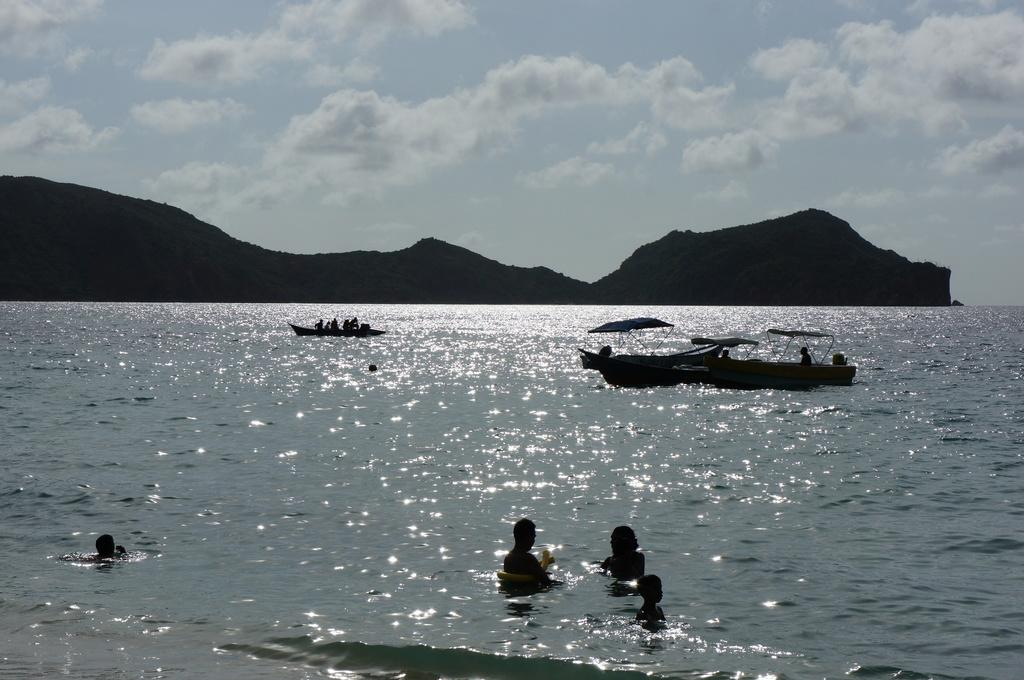What is the main setting of the image? There is a sea in the image. What are the people in the image doing? There are people swimming in the sea. What else can be seen on the sea in the image? There are boats sailing on the sea. What can be seen in the distance in the image? There are mountains visible in the background of the image. Where is the nearest shop to buy a railway ticket in the image? There is no shop or railway mentioned in the image; it only features a sea, people swimming, boats sailing, and mountains in the background. 